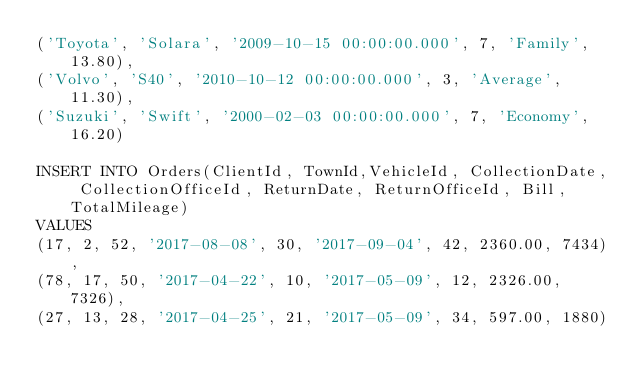Convert code to text. <code><loc_0><loc_0><loc_500><loc_500><_SQL_>('Toyota', 'Solara', '2009-10-15 00:00:00.000', 7, 'Family', 13.80),
('Volvo', 'S40', '2010-10-12 00:00:00.000', 3, 'Average', 11.30),
('Suzuki', 'Swift', '2000-02-03 00:00:00.000', 7, 'Economy', 16.20)

INSERT INTO Orders(ClientId, TownId,VehicleId, CollectionDate, CollectionOfficeId, ReturnDate, ReturnOfficeId, Bill, TotalMileage)
VALUES
(17, 2, 52,	'2017-08-08', 30, '2017-09-04', 42,	2360.00, 7434),
(78, 17, 50, '2017-04-22', 10, '2017-05-09', 12, 2326.00, 7326),
(27, 13, 28, '2017-04-25', 21, '2017-05-09', 34, 597.00, 1880)</code> 